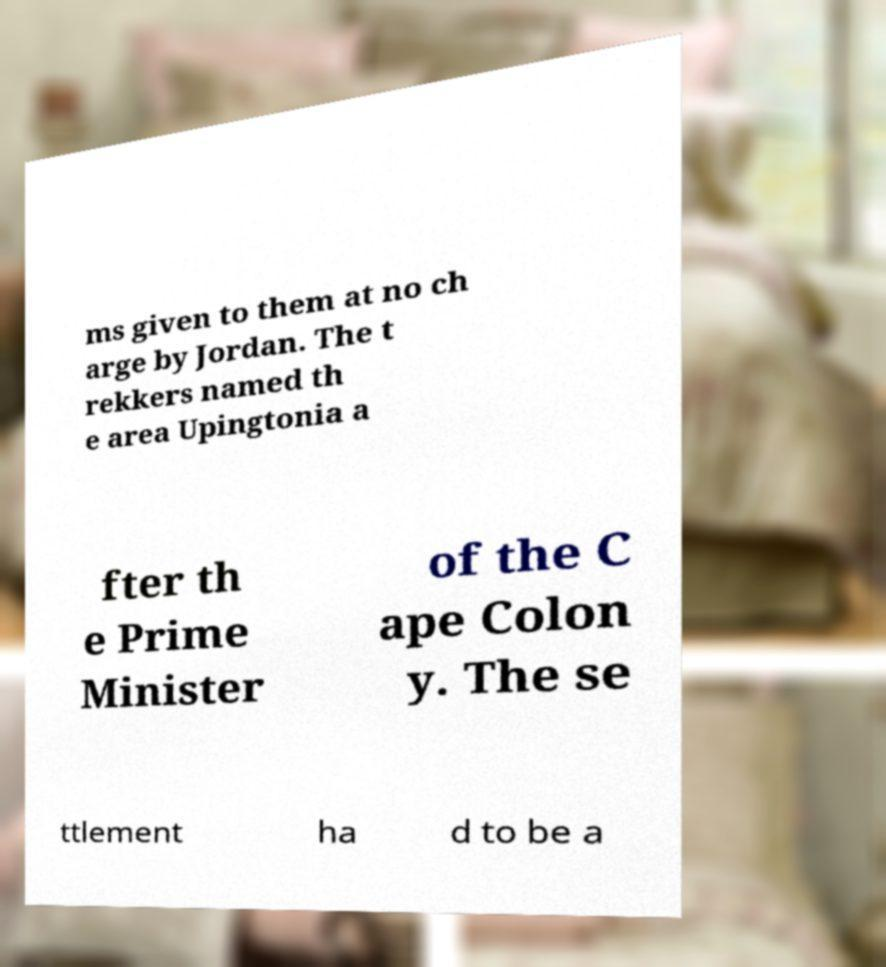Can you read and provide the text displayed in the image?This photo seems to have some interesting text. Can you extract and type it out for me? ms given to them at no ch arge by Jordan. The t rekkers named th e area Upingtonia a fter th e Prime Minister of the C ape Colon y. The se ttlement ha d to be a 